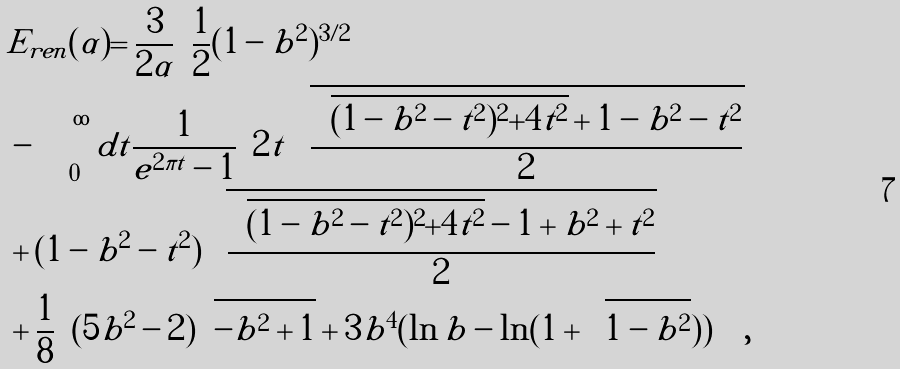Convert formula to latex. <formula><loc_0><loc_0><loc_500><loc_500>& E _ { r e n } ( \alpha ) = \frac { 3 } { 2 \alpha } \Big { ( } \frac { 1 } { 2 } ( 1 - b ^ { 2 } ) ^ { 3 / 2 } \\ & - \int _ { 0 } ^ { \infty } d t \frac { 1 } { e ^ { 2 \pi t } - 1 } \Big { [ } 2 t \sqrt { \frac { \sqrt { ( 1 - b ^ { 2 } - t ^ { 2 } ) ^ { 2 } + 4 t ^ { 2 } } + 1 - b ^ { 2 } - t ^ { 2 } } { 2 } } \\ & + ( 1 - b ^ { 2 } - t ^ { 2 } ) \sqrt { \frac { \sqrt { ( 1 - b ^ { 2 } - t ^ { 2 } ) ^ { 2 } + 4 t ^ { 2 } } - 1 + b ^ { 2 } + t ^ { 2 } } { 2 } } \Big { ] } \\ & + \frac { 1 } { 8 } \Big { ( } ( 5 b ^ { 2 } - 2 ) \sqrt { - b ^ { 2 } + 1 } + 3 b ^ { 4 } ( \ln b - \ln ( 1 + \sqrt { 1 - b ^ { 2 } } ) ) \Big { ) } \Big { ) } ,</formula> 